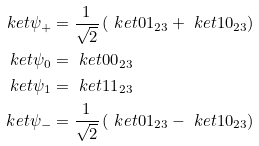Convert formula to latex. <formula><loc_0><loc_0><loc_500><loc_500>\ k e t { \psi _ { + } } & = \frac { 1 } { \sqrt { 2 } } \left ( \ k e t { 0 1 } _ { 2 3 } + \ k e t { 1 0 } _ { 2 3 } \right ) \\ \ k e t { \psi _ { 0 } } & = \ k e t { 0 0 } _ { 2 3 } \\ \ k e t { \psi _ { 1 } } & = \ k e t { 1 1 } _ { 2 3 } \\ \ k e t { \psi _ { - } } & = \frac { 1 } { \sqrt { 2 } } \left ( \ k e t { 0 1 } _ { 2 3 } - \ k e t { 1 0 } _ { 2 3 } \right )</formula> 